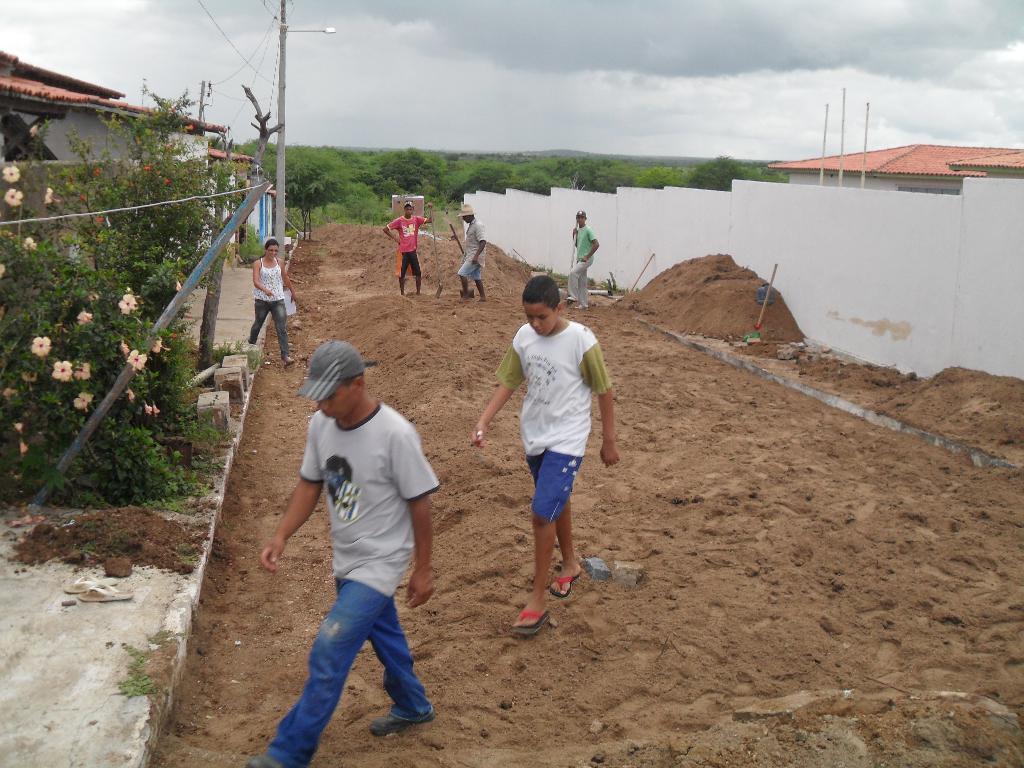How would you summarize this image in a sentence or two? In this picture we can observe some people standing and some of them are walking on the sand. On the left side there are some plants and flowers. We can observe a pole and a house. On the right side there is a wall. In the background there are trees and a sky with clouds. 